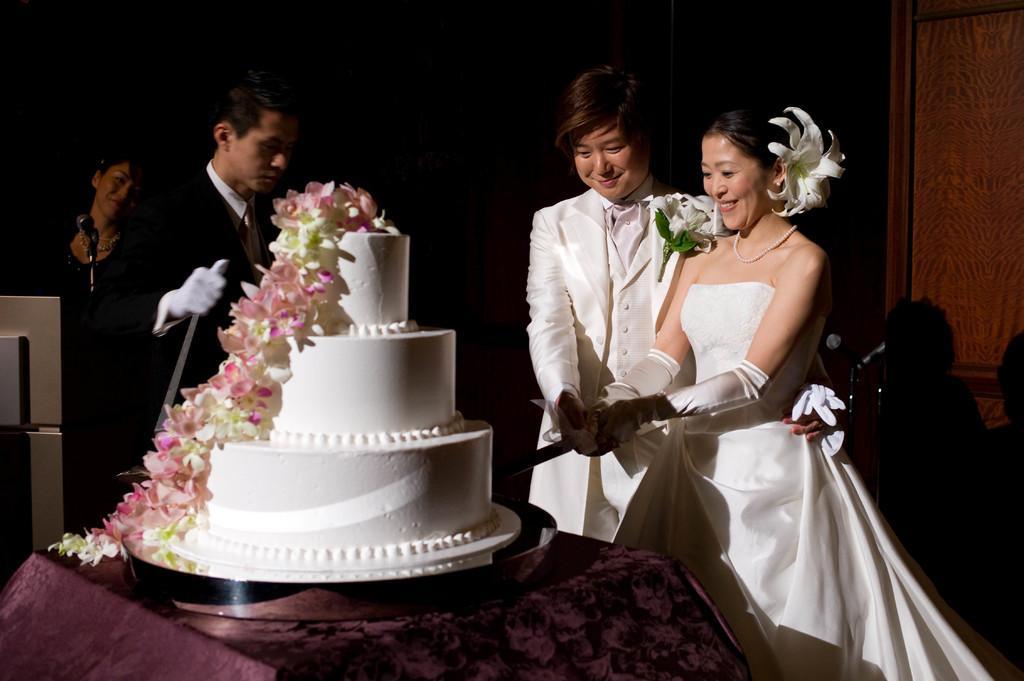Could you give a brief overview of what you see in this image? In this image I can see four persons, mike, knife and a cake on the table. In the background I can see a door and dark color. This image is taken may be in a hall. 